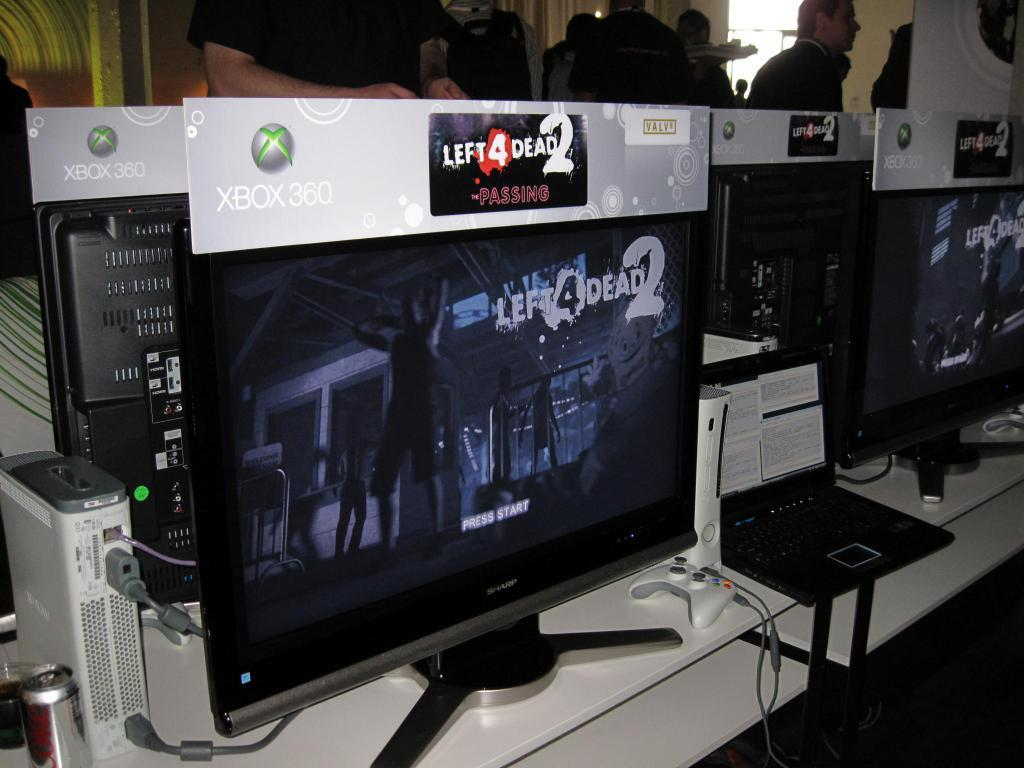<image>
Share a concise interpretation of the image provided. a computer screen with left 4 dead 2 graphics on display 